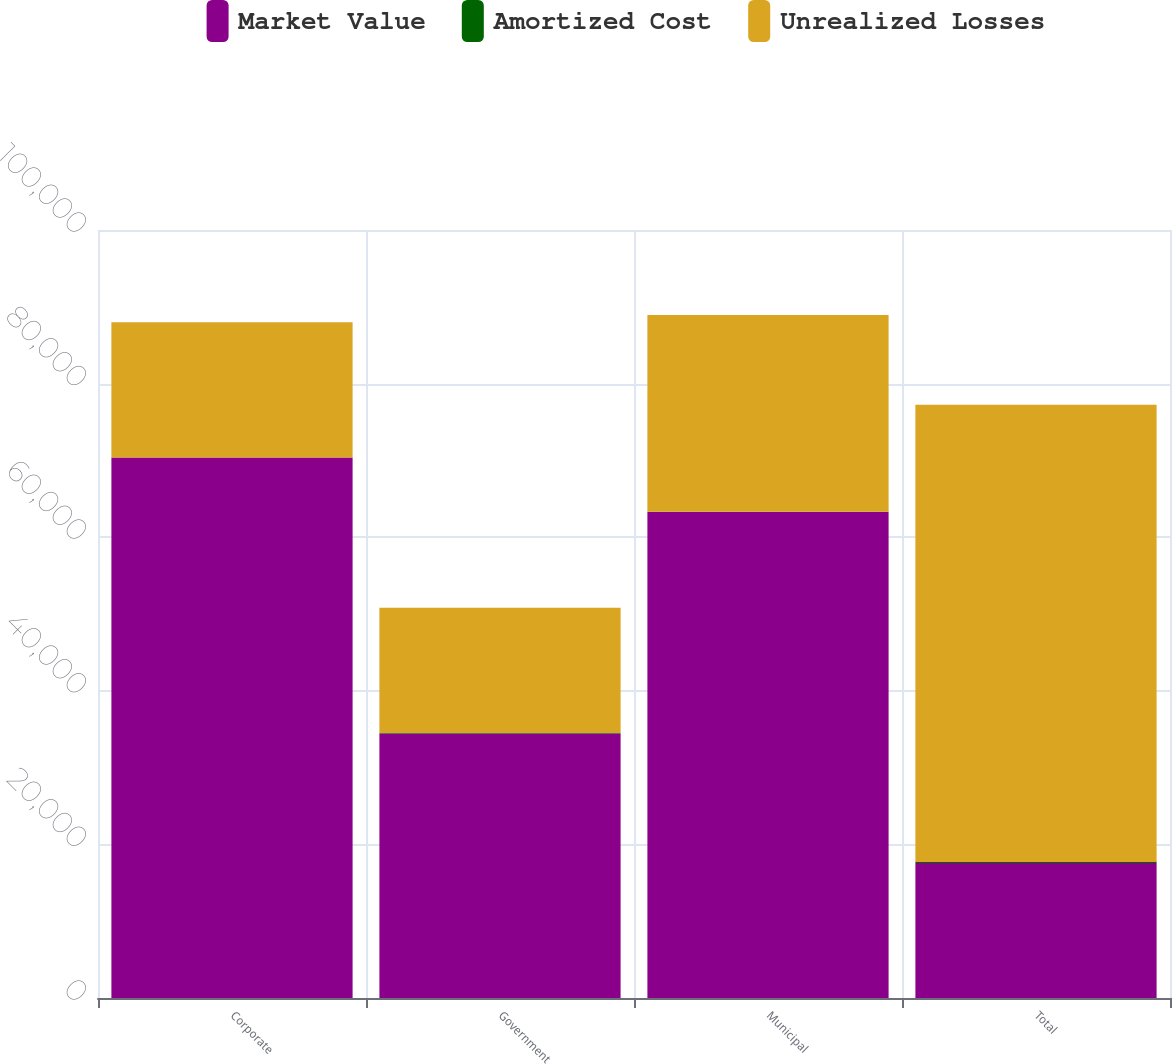<chart> <loc_0><loc_0><loc_500><loc_500><stacked_bar_chart><ecel><fcel>Corporate<fcel>Government<fcel>Municipal<fcel>Total<nl><fcel>Market Value<fcel>70379<fcel>34439<fcel>63281<fcel>17594<nl><fcel>Amortized Cost<fcel>11<fcel>65<fcel>46<fcel>122<nl><fcel>Unrealized Losses<fcel>17594<fcel>16326<fcel>25621<fcel>59541<nl></chart> 